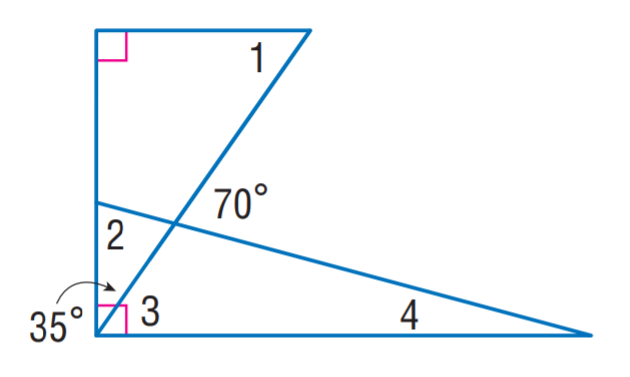Answer the mathemtical geometry problem and directly provide the correct option letter.
Question: Find m \angle 1.
Choices: A: 15 B: 35 C: 55 D: 70 C 